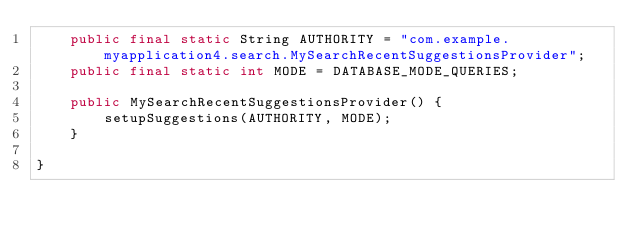<code> <loc_0><loc_0><loc_500><loc_500><_Java_>    public final static String AUTHORITY = "com.example.myapplication4.search.MySearchRecentSuggestionsProvider";
    public final static int MODE = DATABASE_MODE_QUERIES;

    public MySearchRecentSuggestionsProvider() {
        setupSuggestions(AUTHORITY, MODE);
    }

}
</code> 